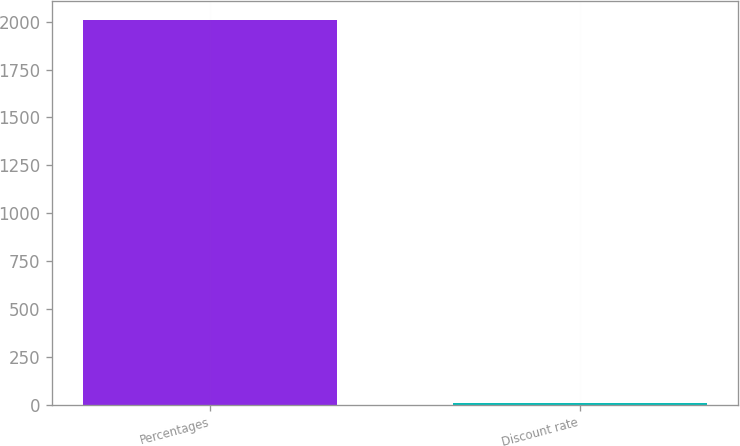Convert chart. <chart><loc_0><loc_0><loc_500><loc_500><bar_chart><fcel>Percentages<fcel>Discount rate<nl><fcel>2007<fcel>6.5<nl></chart> 